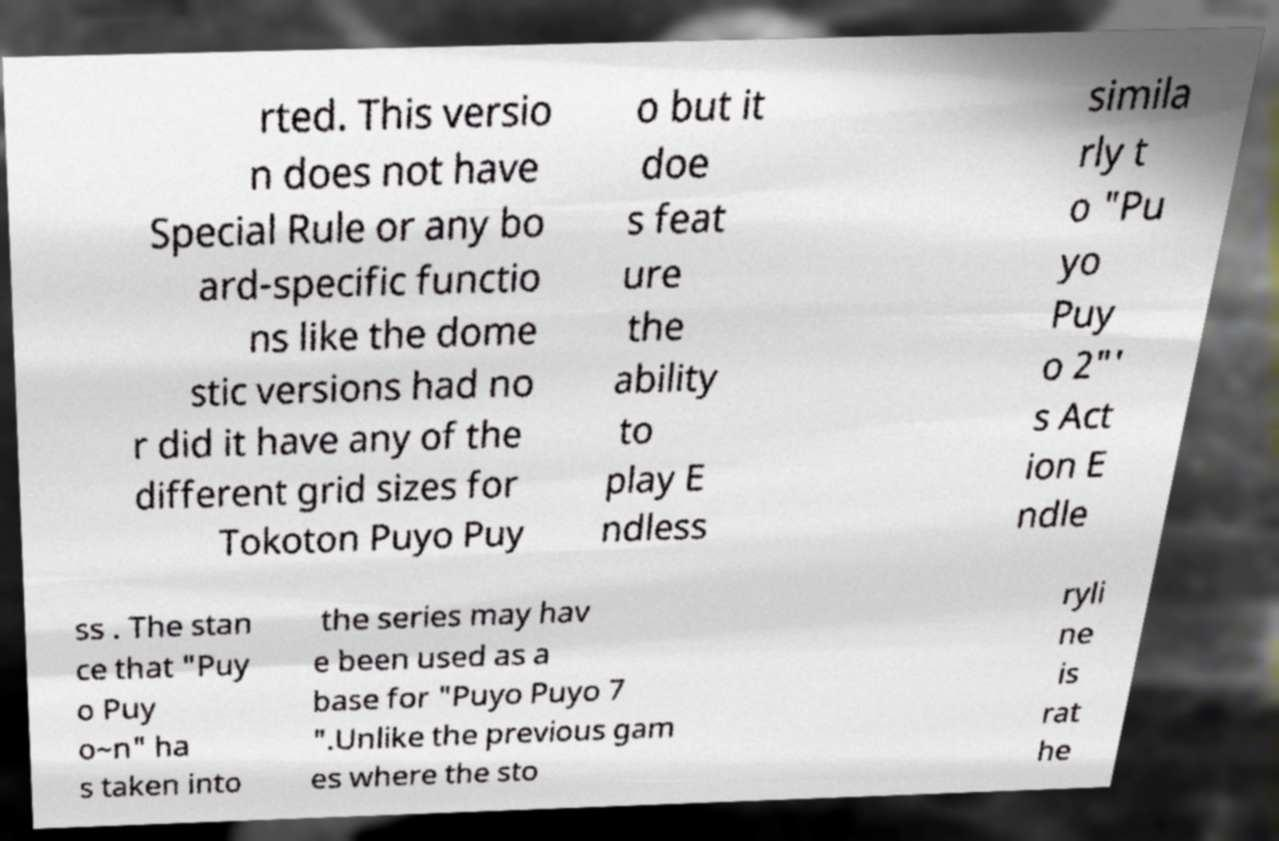Please read and relay the text visible in this image. What does it say? rted. This versio n does not have Special Rule or any bo ard-specific functio ns like the dome stic versions had no r did it have any of the different grid sizes for Tokoton Puyo Puy o but it doe s feat ure the ability to play E ndless simila rly t o "Pu yo Puy o 2"' s Act ion E ndle ss . The stan ce that "Puy o Puy o~n" ha s taken into the series may hav e been used as a base for "Puyo Puyo 7 ".Unlike the previous gam es where the sto ryli ne is rat he 